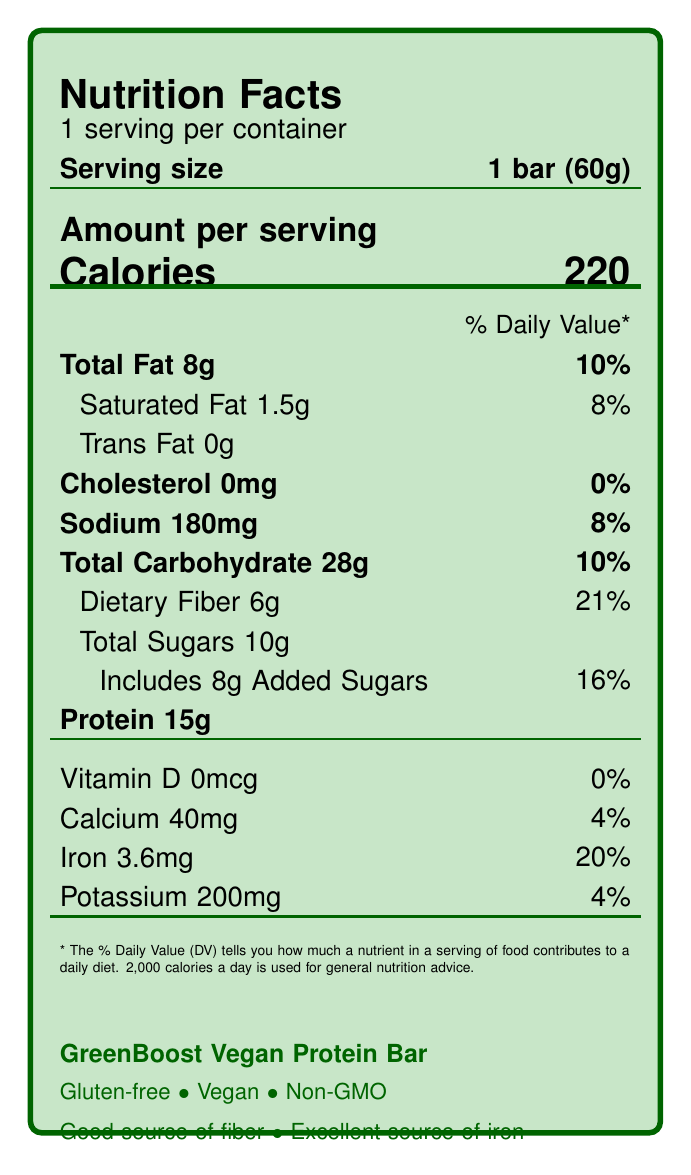What is the daily value percentage of dietary fiber in the GreenBoost Vegan Protein Bar? The label states that the dietary fiber content is 6g, which amounts to 21% of the daily value.
Answer: 21% How much iron is in a serving of the GreenBoost Vegan Protein Bar? The label lists the iron content as 3.6mg per serving.
Answer: 3.6mg How many servings are there in one container of the GreenBoost Vegan Protein Bar? The label clearly mentions that there is 1 serving per container.
Answer: 1 What is the serving size for the GreenBoost Vegan Protein Bar? The label specifies the serving size as 1 bar (60g).
Answer: 1 bar (60g) How many calories are in one serving of the GreenBoost Vegan Protein Bar? The label indicates that there are 220 calories per serving.
Answer: 220 Which nutrient has the highest daily value percentage in the GreenBoost Vegan Protein Bar? A. Total Fat B. Iron C. Dietary Fiber D. Sodium The dietary fiber has the highest daily value percentage at 21%, compared to total fat (10%), iron (20%), and sodium (8%).
Answer: C. Dietary Fiber What is the percentage daily value of iron in the GreenBoost Vegan Protein Bar? A. 4% B. 8% C. 20% D. 21% The label specifies that the percentage daily value of iron is 20%.
Answer: C. 20% Is the GreenBoost Vegan Protein Bar gluten-free? The claim statements on the label mention that the bar is gluten-free.
Answer: Yes Summarize the main features of the GreenBoost Vegan Protein Bar. This summary captures the essential information about the product's nutritional content, health claims, and dietary restrictions from the label.
Answer: The GreenBoost Vegan Protein Bar is a gluten-free, vegan, and non-GMO snack. It contains 220 calories per serving, with 8g of fat, 6g of dietary fiber (21% daily value), and 3.6mg of iron (20% daily value). It also has claim statements of no artificial sweeteners, being a good source of fiber, and an excellent source of iron. What is the source of protein in the GreenBoost Vegan Protein Bar? The document does not provide specific information about the source of protein, aside from listing the general ingredients.
Answer: Cannot be determined What is the percentage of added sugars in the GreenBoost Vegan Protein Bar? According to the label, the bar includes 8g of added sugars, which constitutes 16% of the daily value.
Answer: 16% How much protein does one GreenBoost Vegan Protein Bar contain? The label states that each bar contains 15g of protein.
Answer: 15g What claims does the GreenBoost Vegan Protein Bar make about its nutritional benefits? A. Good source of fiber B. Excellent source of iron C. Low in calories D. No artificial sweeteners E. Both A, B, and D The label claims that the bar is a good source of fiber, an excellent source of iron, and has no artificial sweeteners.
Answer: E. Both A, B, and D What is the total carbohydrate content in one bar? The label lists the total carbohydrate content as 28g per serving.
Answer: 28g 